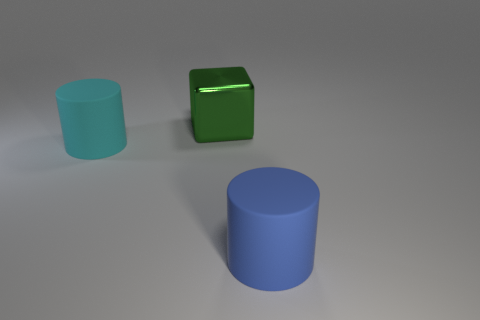Add 3 brown objects. How many objects exist? 6 Subtract all cylinders. How many objects are left? 1 Subtract all cyan things. Subtract all cyan objects. How many objects are left? 1 Add 2 big blue things. How many big blue things are left? 3 Add 2 metal blocks. How many metal blocks exist? 3 Subtract 0 green balls. How many objects are left? 3 